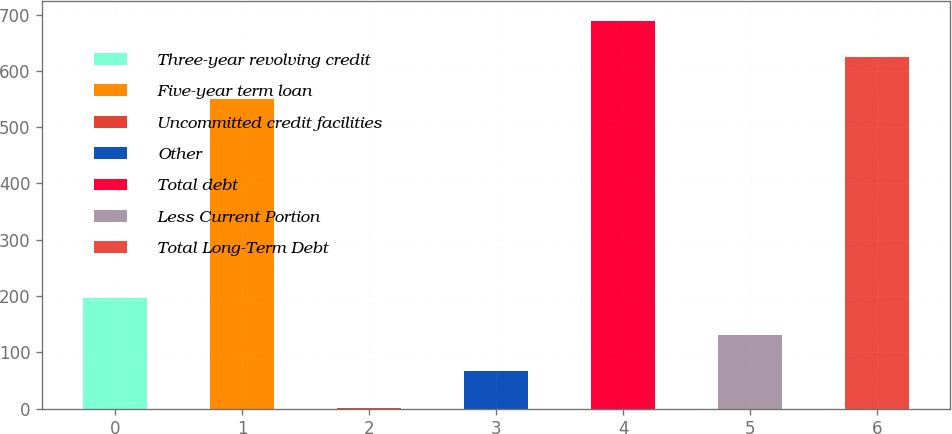<chart> <loc_0><loc_0><loc_500><loc_500><bar_chart><fcel>Three-year revolving credit<fcel>Five-year term loan<fcel>Uncommitted credit facilities<fcel>Other<fcel>Total debt<fcel>Less Current Portion<fcel>Total Long-Term Debt<nl><fcel>196.22<fcel>550<fcel>1.1<fcel>66.14<fcel>689.04<fcel>131.18<fcel>624<nl></chart> 